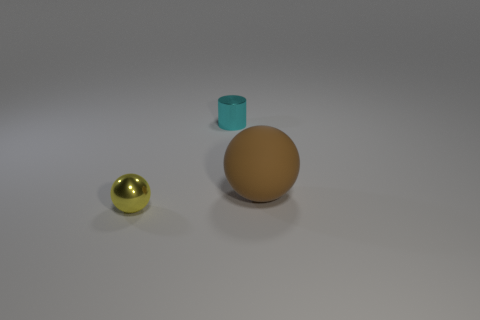Add 1 cyan rubber spheres. How many objects exist? 4 Subtract all spheres. How many objects are left? 1 Add 3 small shiny balls. How many small shiny balls are left? 4 Add 3 metal things. How many metal things exist? 5 Subtract 0 cyan cubes. How many objects are left? 3 Subtract all matte spheres. Subtract all large rubber spheres. How many objects are left? 1 